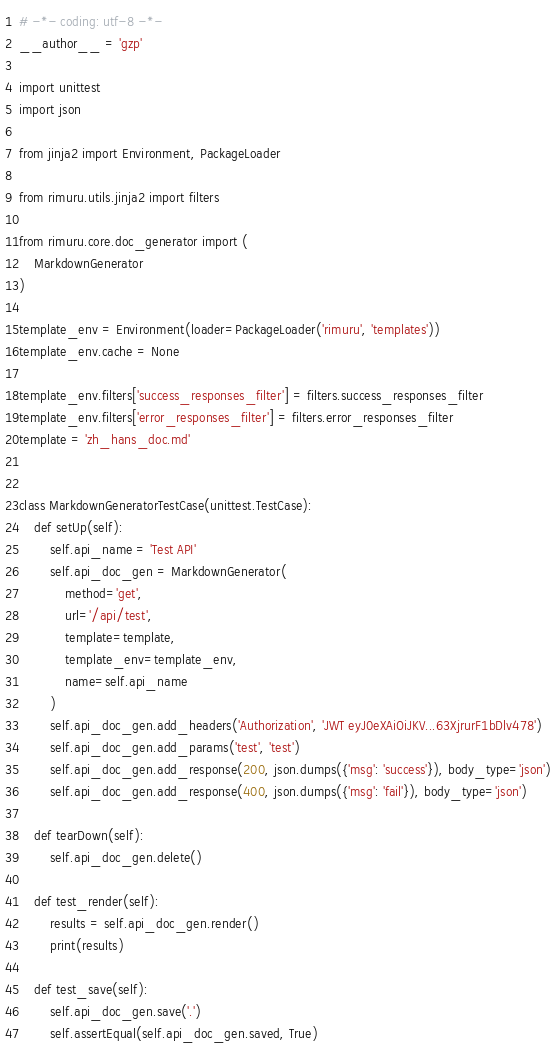Convert code to text. <code><loc_0><loc_0><loc_500><loc_500><_Python_># -*- coding: utf-8 -*-
__author__ = 'gzp'

import unittest
import json

from jinja2 import Environment, PackageLoader

from rimuru.utils.jinja2 import filters

from rimuru.core.doc_generator import (
    MarkdownGenerator
)

template_env = Environment(loader=PackageLoader('rimuru', 'templates'))
template_env.cache = None

template_env.filters['success_responses_filter'] = filters.success_responses_filter
template_env.filters['error_responses_filter'] = filters.error_responses_filter
template = 'zh_hans_doc.md'


class MarkdownGeneratorTestCase(unittest.TestCase):
    def setUp(self):
        self.api_name = 'Test API'
        self.api_doc_gen = MarkdownGenerator(
            method='get',
            url='/api/test',
            template=template,
            template_env=template_env,
            name=self.api_name
        )
        self.api_doc_gen.add_headers('Authorization', 'JWT eyJ0eXAiOiJKV...63XjrurF1bDlv478')
        self.api_doc_gen.add_params('test', 'test')
        self.api_doc_gen.add_response(200, json.dumps({'msg': 'success'}), body_type='json')
        self.api_doc_gen.add_response(400, json.dumps({'msg': 'fail'}), body_type='json')

    def tearDown(self):
        self.api_doc_gen.delete()

    def test_render(self):
        results = self.api_doc_gen.render()
        print(results)

    def test_save(self):
        self.api_doc_gen.save('.')
        self.assertEqual(self.api_doc_gen.saved, True)
</code> 